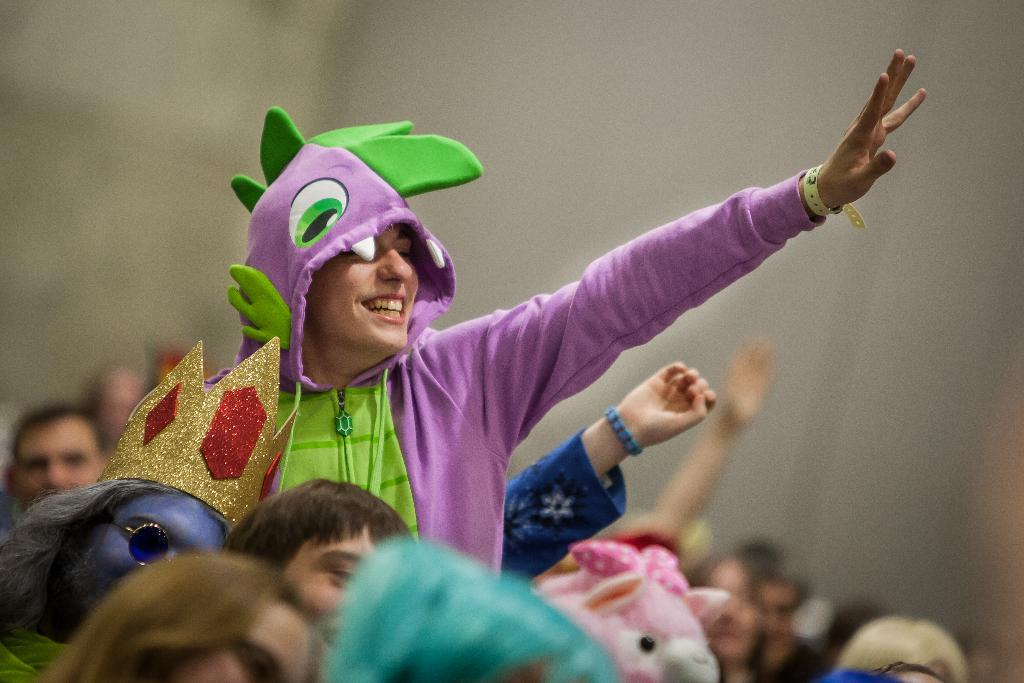What is the main subject of the image? There is a group of people in the front of the image. How is the background of the image depicted? The background of the image is blurred. Can you describe the appearance of one of the people in the image? A woman is wearing a pink dress in the image. What type of meat can be seen hanging from the chin of the woman in the pink dress? There is no meat or chin visible in the image, and therefore no such activity can be observed. 